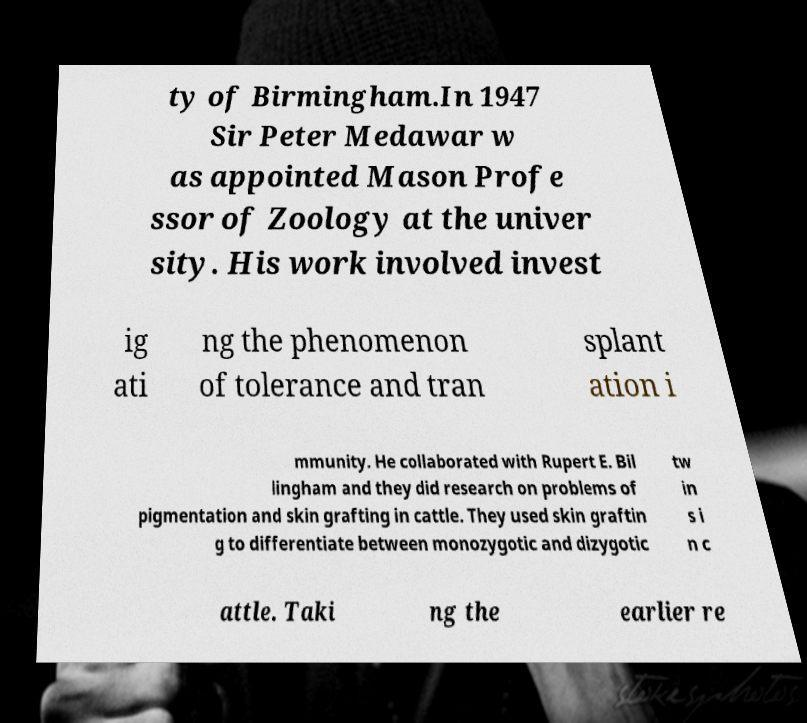Can you read and provide the text displayed in the image?This photo seems to have some interesting text. Can you extract and type it out for me? ty of Birmingham.In 1947 Sir Peter Medawar w as appointed Mason Profe ssor of Zoology at the univer sity. His work involved invest ig ati ng the phenomenon of tolerance and tran splant ation i mmunity. He collaborated with Rupert E. Bil lingham and they did research on problems of pigmentation and skin grafting in cattle. They used skin graftin g to differentiate between monozygotic and dizygotic tw in s i n c attle. Taki ng the earlier re 